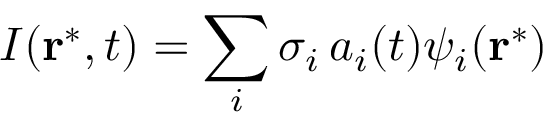Convert formula to latex. <formula><loc_0><loc_0><loc_500><loc_500>I ( r ^ { * } , t ) = \sum _ { i } \sigma _ { i } \, a _ { i } ( t ) \psi _ { i } ( r ^ { * } )</formula> 